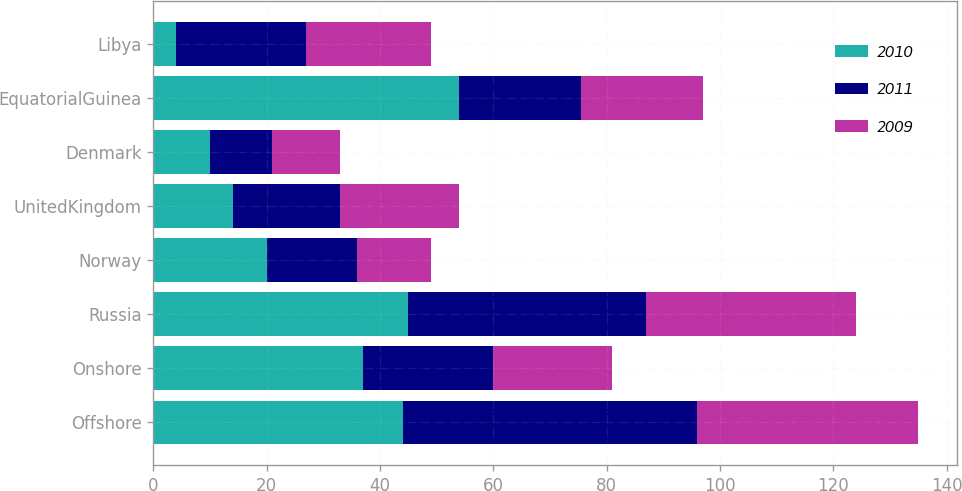Convert chart to OTSL. <chart><loc_0><loc_0><loc_500><loc_500><stacked_bar_chart><ecel><fcel>Offshore<fcel>Onshore<fcel>Russia<fcel>Norway<fcel>UnitedKingdom<fcel>Denmark<fcel>EquatorialGuinea<fcel>Libya<nl><fcel>2010<fcel>44<fcel>37<fcel>45<fcel>20<fcel>14<fcel>10<fcel>54<fcel>4<nl><fcel>2011<fcel>52<fcel>23<fcel>42<fcel>16<fcel>19<fcel>11<fcel>21.5<fcel>23<nl><fcel>2009<fcel>39<fcel>21<fcel>37<fcel>13<fcel>21<fcel>12<fcel>21.5<fcel>22<nl></chart> 